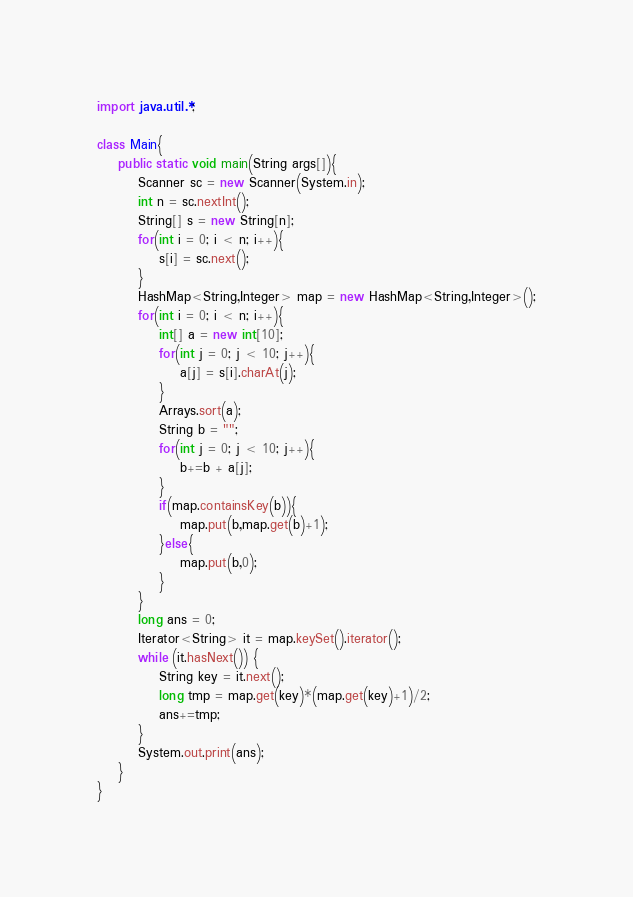<code> <loc_0><loc_0><loc_500><loc_500><_Java_>import java.util.*;

class Main{
	public static void main(String args[]){
		Scanner sc = new Scanner(System.in);
		int n = sc.nextInt();
		String[] s = new String[n];
		for(int i = 0; i < n; i++){
			s[i] = sc.next();
		}
		HashMap<String,Integer> map = new HashMap<String,Integer>();
		for(int i = 0; i < n; i++){
			int[] a = new int[10];
			for(int j = 0; j < 10; j++){
				a[j] = s[i].charAt(j);
			}
			Arrays.sort(a);
			String b = "";
			for(int j = 0; j < 10; j++){
				b+=b + a[j];
			}
			if(map.containsKey(b)){
				map.put(b,map.get(b)+1);
			}else{
				map.put(b,0);
			}
		}
		long ans = 0;
		Iterator<String> it = map.keySet().iterator();
		while (it.hasNext()) {
			String key = it.next();
			long tmp = map.get(key)*(map.get(key)+1)/2;
			ans+=tmp;
		}
		System.out.print(ans);
	}
}
</code> 